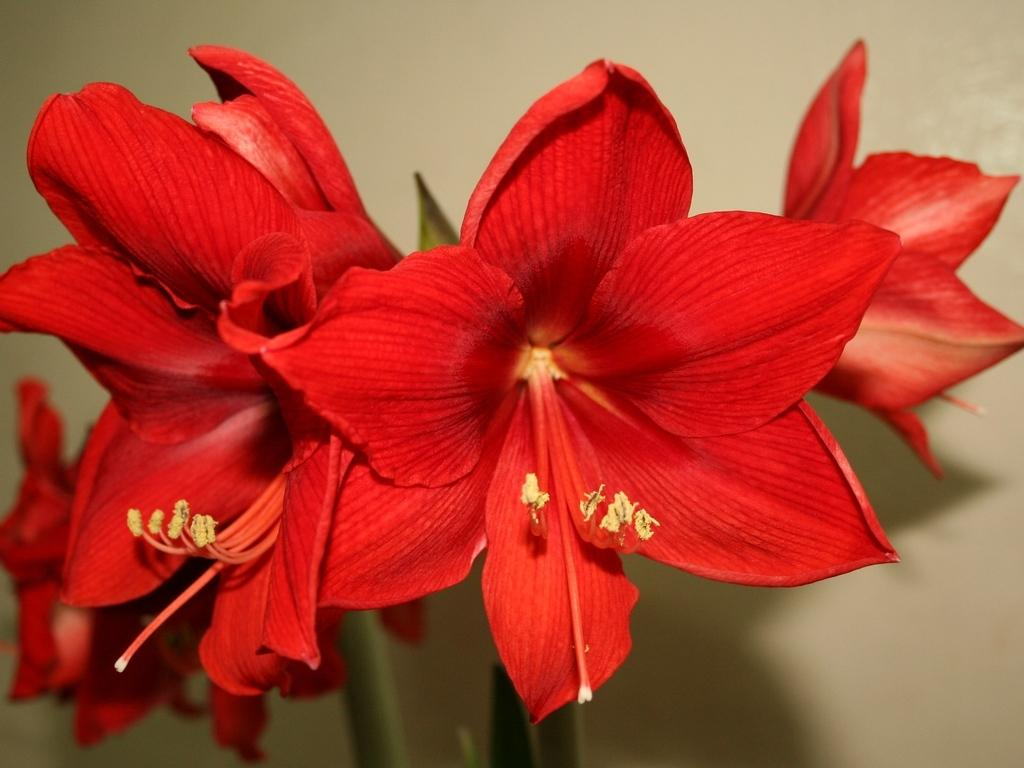What type of flowers can be seen in the image? There are red color flowers in the image. What type of curtain is hanging in the background of the image? There is no curtain present in the image; it only features red color flowers. 